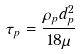Convert formula to latex. <formula><loc_0><loc_0><loc_500><loc_500>\tau _ { p } = \frac { \rho _ { p } d _ { p } ^ { 2 } } { 1 8 \mu }</formula> 